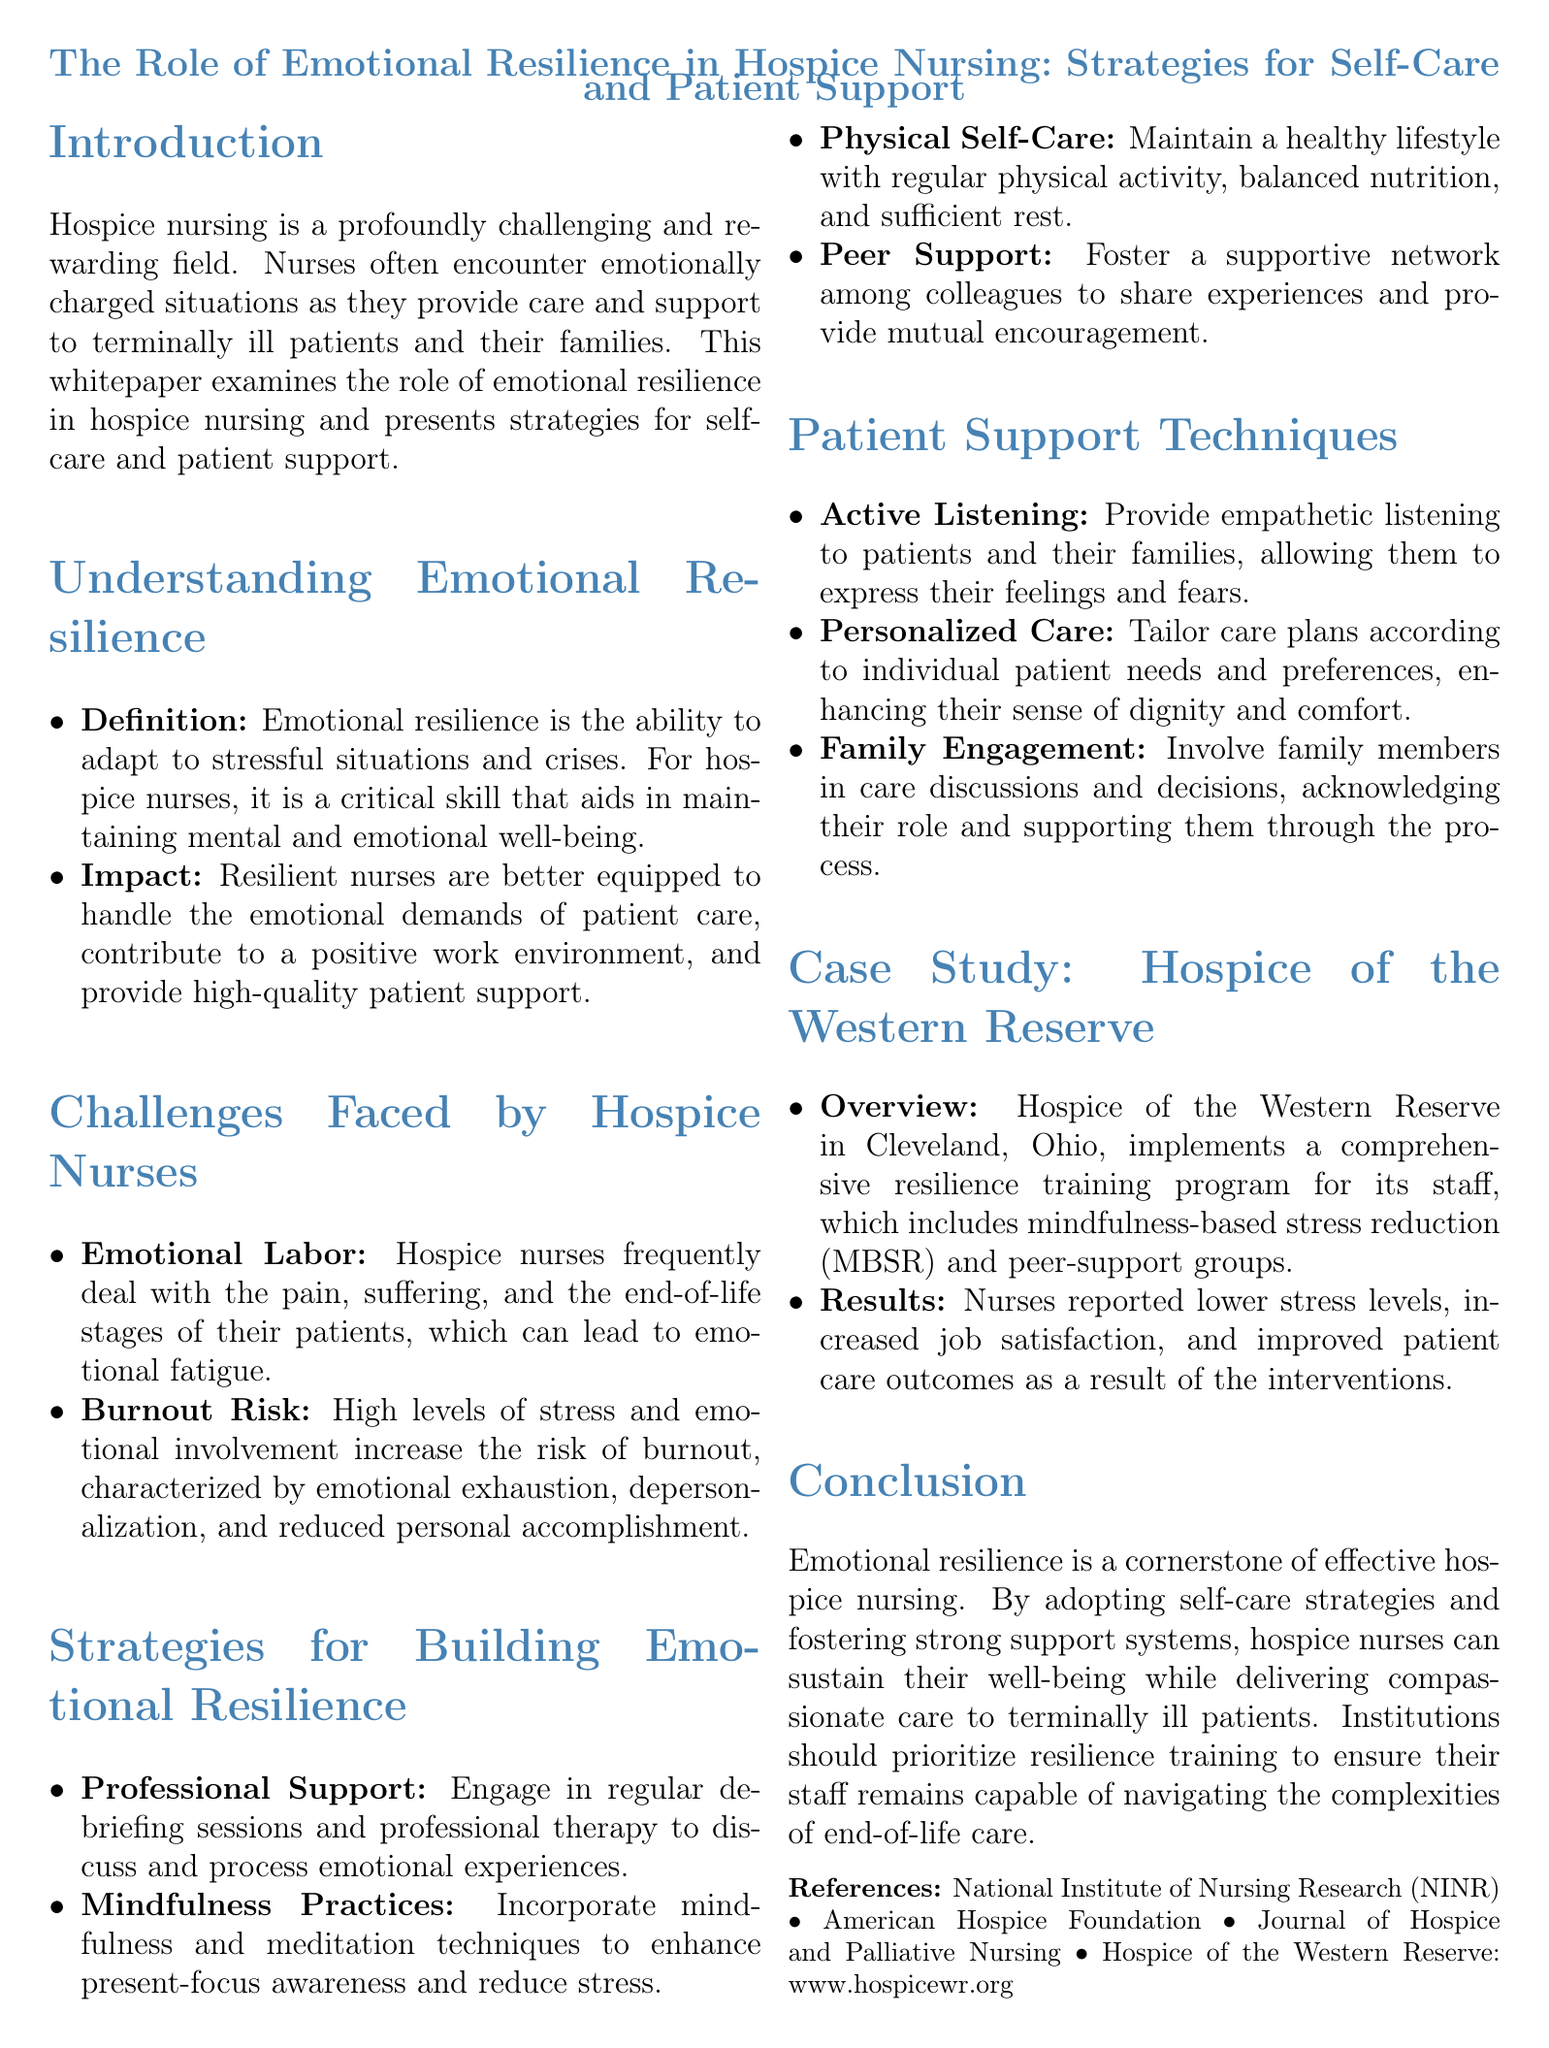what is the primary focus of the whitepaper? The primary focus is on the role of emotional resilience in hospice nursing.
Answer: emotional resilience in hospice nursing what practice is recommended for reducing stress? Mindfulness and meditation techniques are suggested to enhance present-focus awareness and reduce stress.
Answer: mindfulness practices which organization implemented a resilience training program? The name of the organization implementing a resilience training program is mentioned in the case study section.
Answer: Hospice of the Western Reserve what are the components of emotional labor faced by hospice nurses? The emotional labor involves dealing with pain and suffering of patients and the end-of-life stages.
Answer: pain and suffering, end-of-life stages how many risk factors for burnout are mentioned? Two specific risk factors for burnout are identified in the challenges section.
Answer: two how do resilient nurses impact their work environment? Resilient nurses contribute to a positive work environment as stated in the document.
Answer: positive work environment what type of care is emphasized for patients? The document emphasizes providing personalized care tailored to individual patient needs.
Answer: personalized care name one strategy for professional support. The document mentions engaging in regular debriefing sessions as a professional support strategy.
Answer: debriefing sessions 